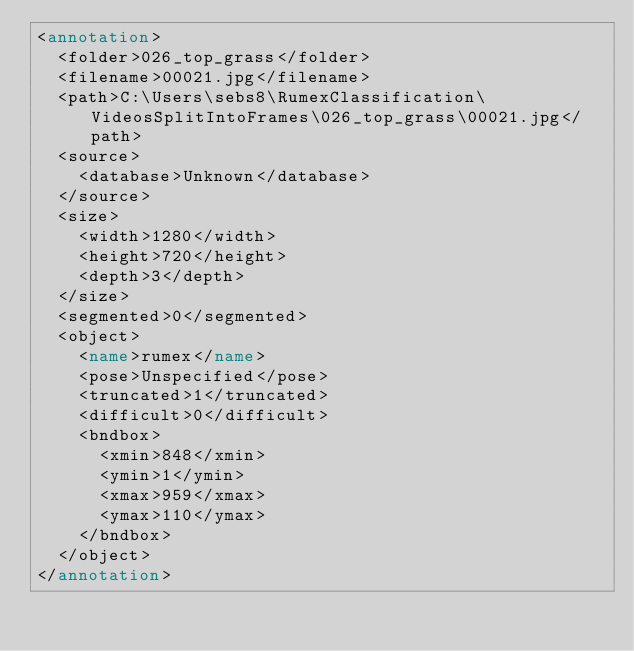Convert code to text. <code><loc_0><loc_0><loc_500><loc_500><_XML_><annotation>
	<folder>026_top_grass</folder>
	<filename>00021.jpg</filename>
	<path>C:\Users\sebs8\RumexClassification\VideosSplitIntoFrames\026_top_grass\00021.jpg</path>
	<source>
		<database>Unknown</database>
	</source>
	<size>
		<width>1280</width>
		<height>720</height>
		<depth>3</depth>
	</size>
	<segmented>0</segmented>
	<object>
		<name>rumex</name>
		<pose>Unspecified</pose>
		<truncated>1</truncated>
		<difficult>0</difficult>
		<bndbox>
			<xmin>848</xmin>
			<ymin>1</ymin>
			<xmax>959</xmax>
			<ymax>110</ymax>
		</bndbox>
	</object>
</annotation>
</code> 